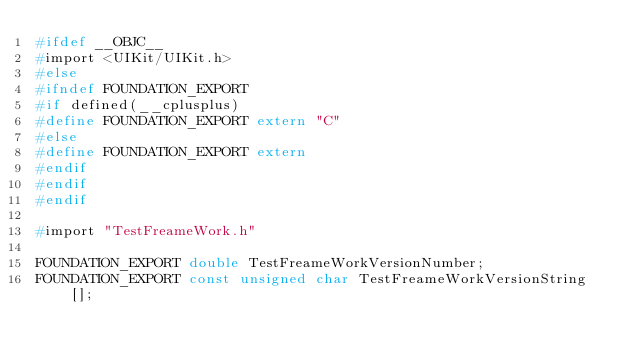<code> <loc_0><loc_0><loc_500><loc_500><_C_>#ifdef __OBJC__
#import <UIKit/UIKit.h>
#else
#ifndef FOUNDATION_EXPORT
#if defined(__cplusplus)
#define FOUNDATION_EXPORT extern "C"
#else
#define FOUNDATION_EXPORT extern
#endif
#endif
#endif

#import "TestFreameWork.h"

FOUNDATION_EXPORT double TestFreameWorkVersionNumber;
FOUNDATION_EXPORT const unsigned char TestFreameWorkVersionString[];

</code> 